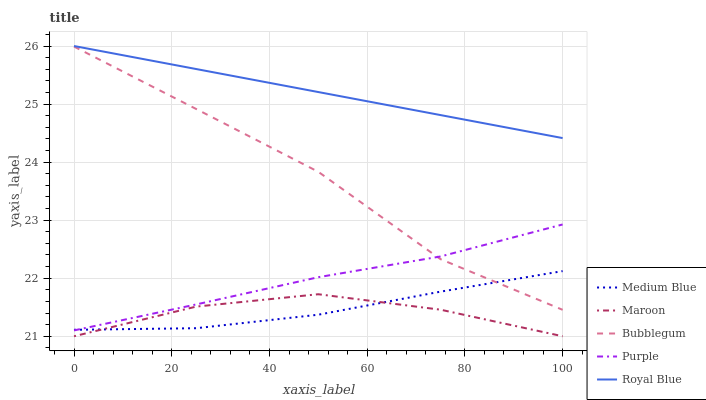Does Maroon have the minimum area under the curve?
Answer yes or no. Yes. Does Royal Blue have the maximum area under the curve?
Answer yes or no. Yes. Does Medium Blue have the minimum area under the curve?
Answer yes or no. No. Does Medium Blue have the maximum area under the curve?
Answer yes or no. No. Is Royal Blue the smoothest?
Answer yes or no. Yes. Is Bubblegum the roughest?
Answer yes or no. Yes. Is Medium Blue the smoothest?
Answer yes or no. No. Is Medium Blue the roughest?
Answer yes or no. No. Does Medium Blue have the lowest value?
Answer yes or no. No. Does Medium Blue have the highest value?
Answer yes or no. No. Is Purple less than Royal Blue?
Answer yes or no. Yes. Is Royal Blue greater than Medium Blue?
Answer yes or no. Yes. Does Purple intersect Royal Blue?
Answer yes or no. No. 